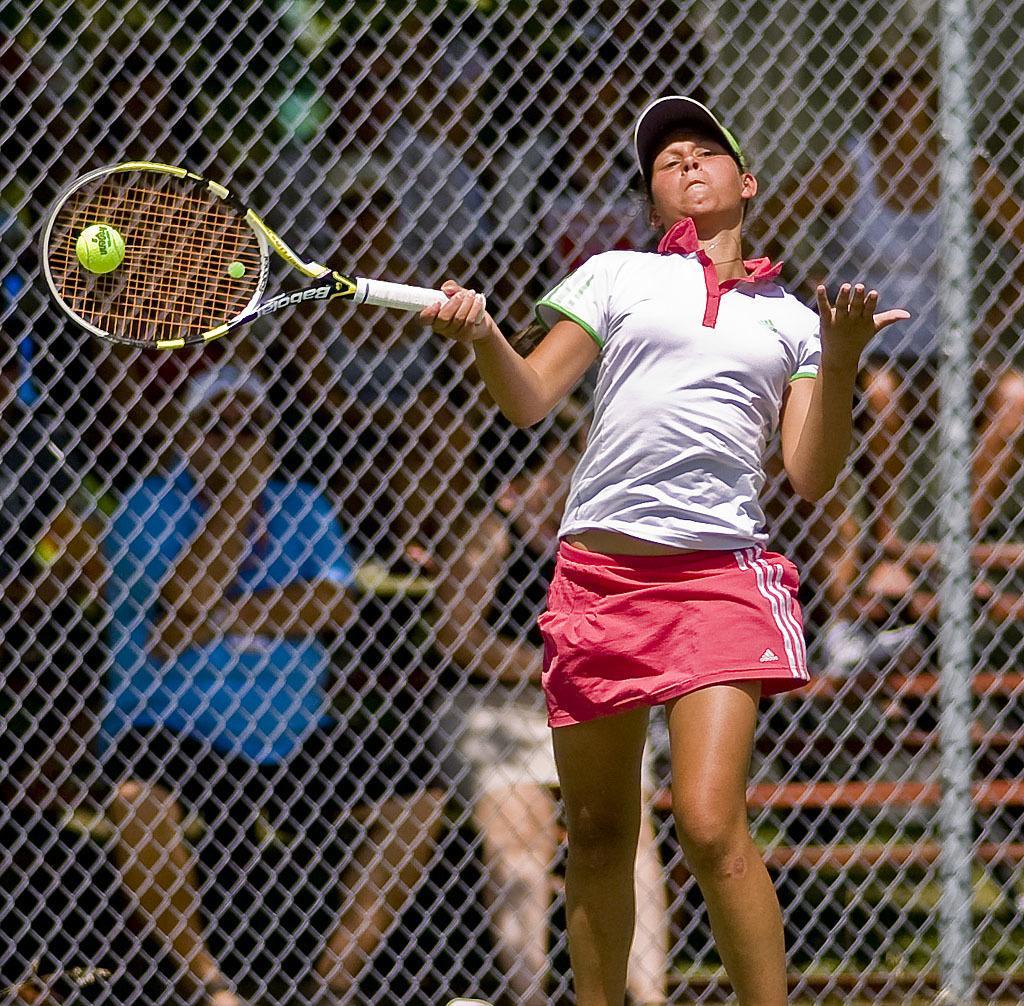Can you describe this image briefly? In this picture I can see a woman in front, who is wearing white color t-shirt and pink color skirt and I see that she is holding a racket and I see a ball near to it. In the background I can see the fencing and I see few people. I can also see that she is wearing a cap. 